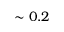Convert formula to latex. <formula><loc_0><loc_0><loc_500><loc_500>\sim 0 . 2</formula> 